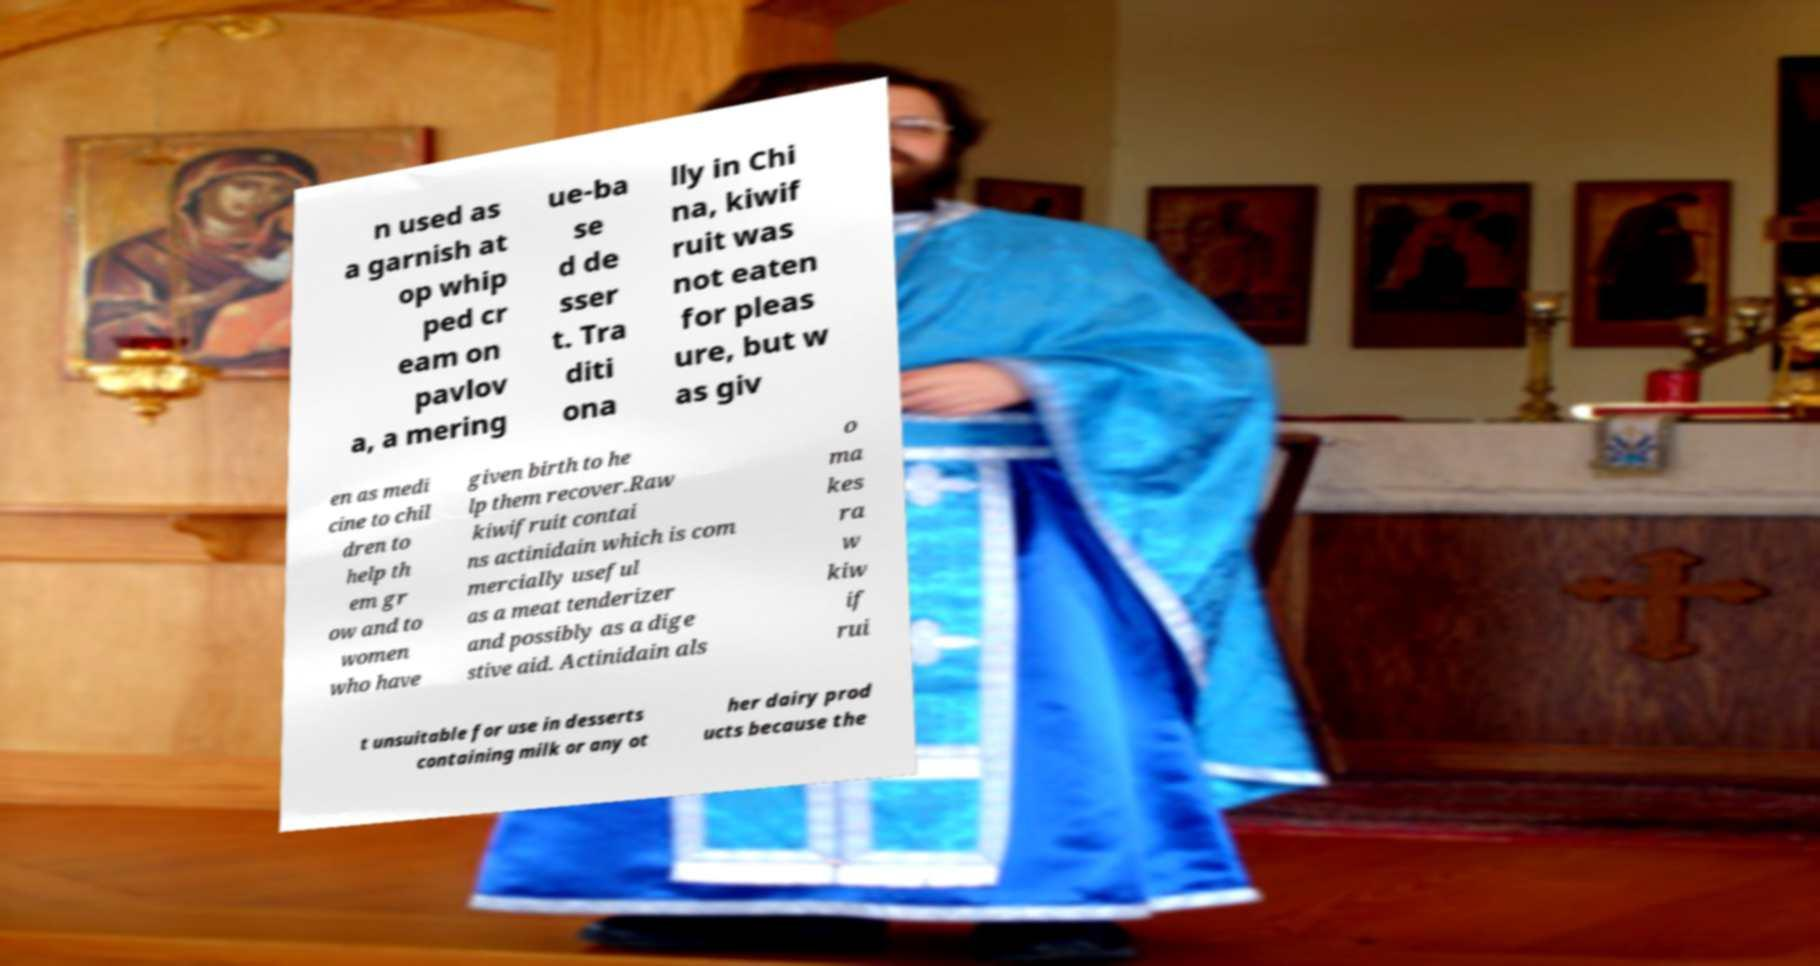For documentation purposes, I need the text within this image transcribed. Could you provide that? n used as a garnish at op whip ped cr eam on pavlov a, a mering ue-ba se d de sser t. Tra diti ona lly in Chi na, kiwif ruit was not eaten for pleas ure, but w as giv en as medi cine to chil dren to help th em gr ow and to women who have given birth to he lp them recover.Raw kiwifruit contai ns actinidain which is com mercially useful as a meat tenderizer and possibly as a dige stive aid. Actinidain als o ma kes ra w kiw if rui t unsuitable for use in desserts containing milk or any ot her dairy prod ucts because the 